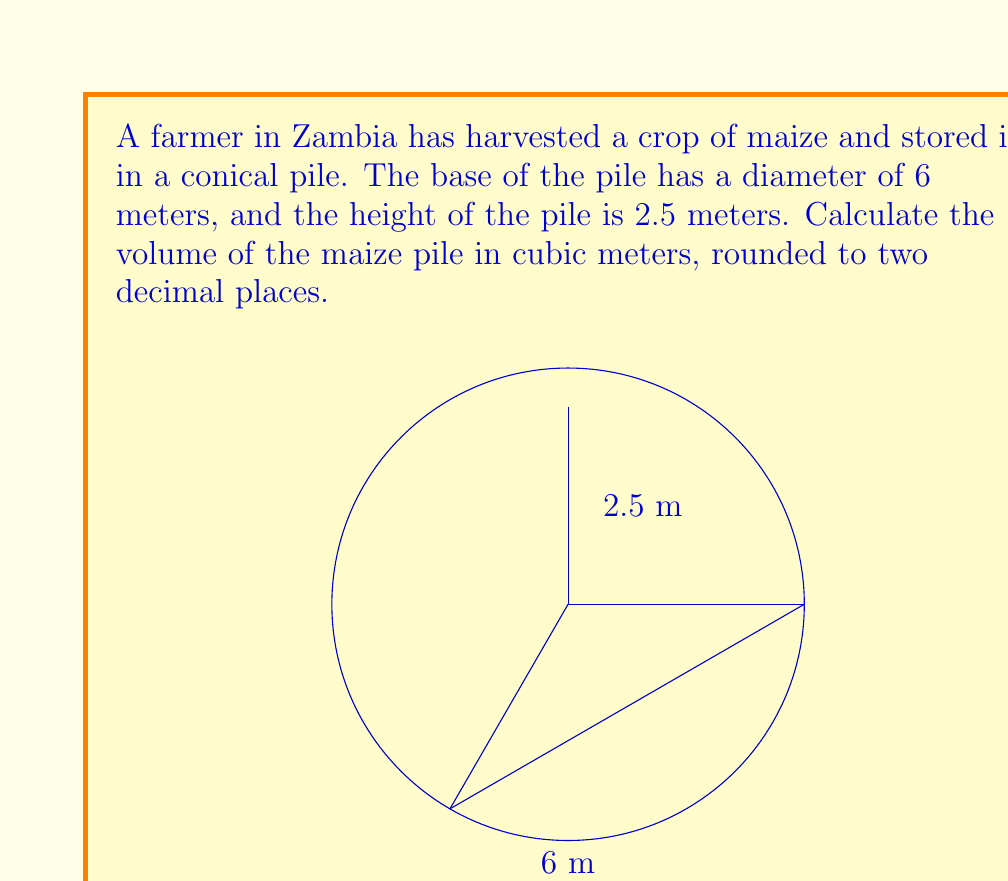Can you solve this math problem? To solve this problem, we need to use the formula for the volume of a cone:

$$V = \frac{1}{3}\pi r^2 h$$

Where:
$V$ = volume of the cone
$r$ = radius of the base
$h$ = height of the cone

Given:
- Diameter of the base = 6 meters
- Height of the pile = 2.5 meters

Step 1: Calculate the radius of the base.
The radius is half the diameter.
$r = 6 \div 2 = 3$ meters

Step 2: Substitute the values into the formula.
$$V = \frac{1}{3}\pi (3\text{ m})^2 (2.5\text{ m})$$

Step 3: Calculate the volume.
$$\begin{align*}
V &= \frac{1}{3}\pi (9\text{ m}^2) (2.5\text{ m}) \\
&= \frac{1}{3} \times 9\pi \text{ m}^3 \times 2.5 \\
&= 7.5\pi \text{ m}^3
\end{align*}$$

Step 4: Evaluate and round to two decimal places.
$$V \approx 23.56 \text{ m}^3$$

Therefore, the volume of the maize pile is approximately 23.56 cubic meters.
Answer: $23.56 \text{ m}^3$ 